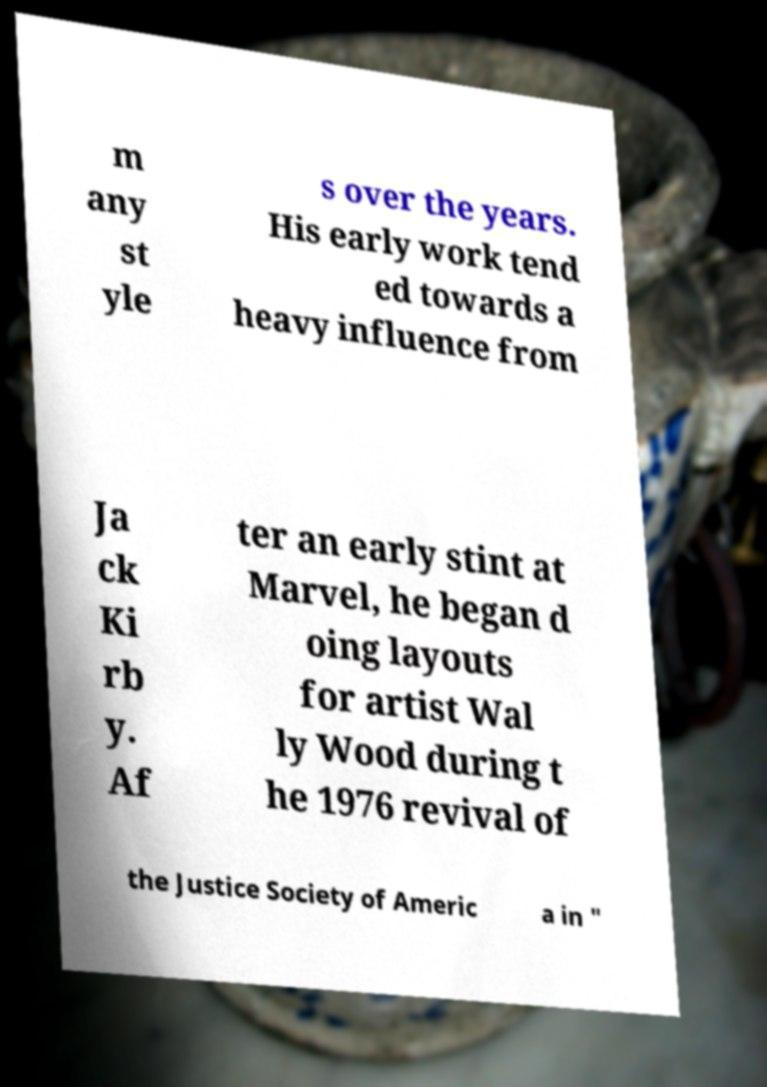I need the written content from this picture converted into text. Can you do that? m any st yle s over the years. His early work tend ed towards a heavy influence from Ja ck Ki rb y. Af ter an early stint at Marvel, he began d oing layouts for artist Wal ly Wood during t he 1976 revival of the Justice Society of Americ a in " 